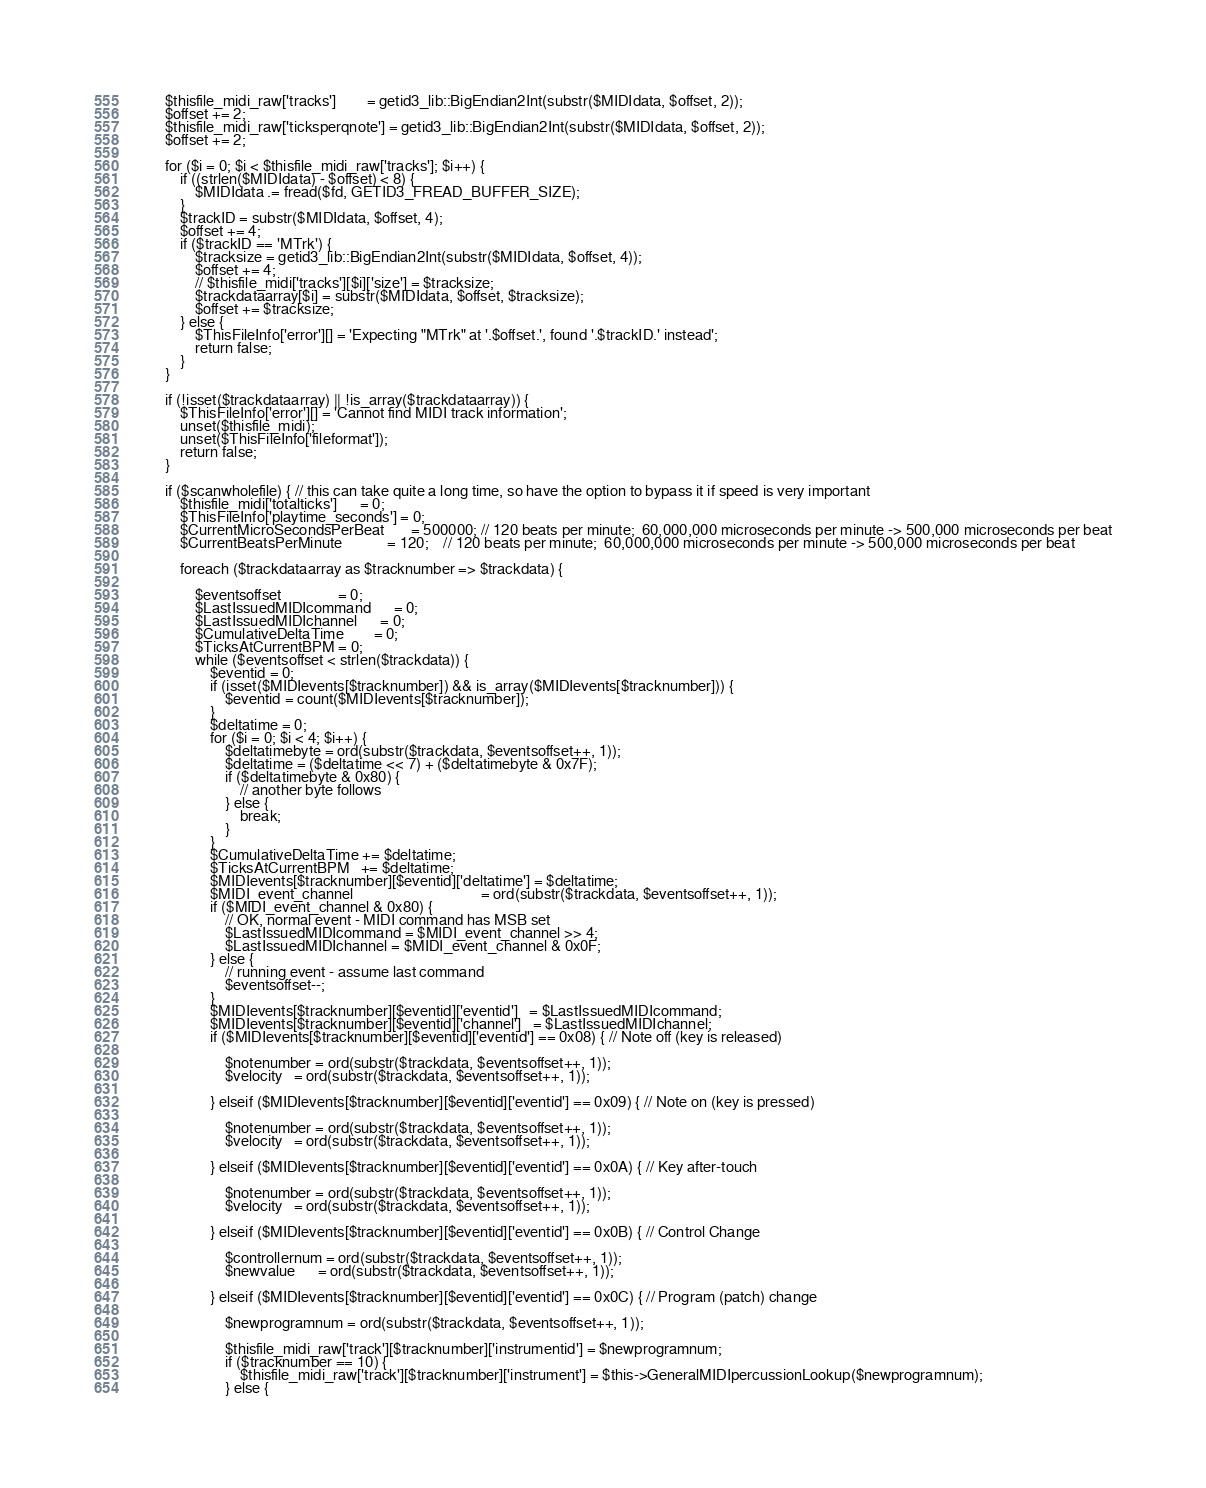Convert code to text. <code><loc_0><loc_0><loc_500><loc_500><_PHP_>		$thisfile_midi_raw['tracks']        = getid3_lib::BigEndian2Int(substr($MIDIdata, $offset, 2));
		$offset += 2;
		$thisfile_midi_raw['ticksperqnote'] = getid3_lib::BigEndian2Int(substr($MIDIdata, $offset, 2));
		$offset += 2;

		for ($i = 0; $i < $thisfile_midi_raw['tracks']; $i++) {
			if ((strlen($MIDIdata) - $offset) < 8) {
				$MIDIdata .= fread($fd, GETID3_FREAD_BUFFER_SIZE);
			}
			$trackID = substr($MIDIdata, $offset, 4);
			$offset += 4;
			if ($trackID == 'MTrk') {
				$tracksize = getid3_lib::BigEndian2Int(substr($MIDIdata, $offset, 4));
				$offset += 4;
				// $thisfile_midi['tracks'][$i]['size'] = $tracksize;
				$trackdataarray[$i] = substr($MIDIdata, $offset, $tracksize);
				$offset += $tracksize;
			} else {
				$ThisFileInfo['error'][] = 'Expecting "MTrk" at '.$offset.', found '.$trackID.' instead';
				return false;
			}
		}

		if (!isset($trackdataarray) || !is_array($trackdataarray)) {
			$ThisFileInfo['error'][] = 'Cannot find MIDI track information';
			unset($thisfile_midi);
			unset($ThisFileInfo['fileformat']);
			return false;
		}

		if ($scanwholefile) { // this can take quite a long time, so have the option to bypass it if speed is very important
			$thisfile_midi['totalticks']      = 0;
			$ThisFileInfo['playtime_seconds'] = 0;
			$CurrentMicroSecondsPerBeat       = 500000; // 120 beats per minute;  60,000,000 microseconds per minute -> 500,000 microseconds per beat
			$CurrentBeatsPerMinute            = 120;    // 120 beats per minute;  60,000,000 microseconds per minute -> 500,000 microseconds per beat

			foreach ($trackdataarray as $tracknumber => $trackdata) {

				$eventsoffset               = 0;
				$LastIssuedMIDIcommand      = 0;
				$LastIssuedMIDIchannel      = 0;
				$CumulativeDeltaTime        = 0;
				$TicksAtCurrentBPM = 0;
				while ($eventsoffset < strlen($trackdata)) {
					$eventid = 0;
					if (isset($MIDIevents[$tracknumber]) && is_array($MIDIevents[$tracknumber])) {
						$eventid = count($MIDIevents[$tracknumber]);
					}
					$deltatime = 0;
					for ($i = 0; $i < 4; $i++) {
						$deltatimebyte = ord(substr($trackdata, $eventsoffset++, 1));
						$deltatime = ($deltatime << 7) + ($deltatimebyte & 0x7F);
						if ($deltatimebyte & 0x80) {
							// another byte follows
						} else {
							break;
						}
					}
					$CumulativeDeltaTime += $deltatime;
					$TicksAtCurrentBPM   += $deltatime;
					$MIDIevents[$tracknumber][$eventid]['deltatime'] = $deltatime;
					$MIDI_event_channel                                  = ord(substr($trackdata, $eventsoffset++, 1));
					if ($MIDI_event_channel & 0x80) {
						// OK, normal event - MIDI command has MSB set
						$LastIssuedMIDIcommand = $MIDI_event_channel >> 4;
						$LastIssuedMIDIchannel = $MIDI_event_channel & 0x0F;
					} else {
						// running event - assume last command
						$eventsoffset--;
					}
					$MIDIevents[$tracknumber][$eventid]['eventid']   = $LastIssuedMIDIcommand;
					$MIDIevents[$tracknumber][$eventid]['channel']   = $LastIssuedMIDIchannel;
					if ($MIDIevents[$tracknumber][$eventid]['eventid'] == 0x08) { // Note off (key is released)

						$notenumber = ord(substr($trackdata, $eventsoffset++, 1));
						$velocity   = ord(substr($trackdata, $eventsoffset++, 1));

					} elseif ($MIDIevents[$tracknumber][$eventid]['eventid'] == 0x09) { // Note on (key is pressed)

						$notenumber = ord(substr($trackdata, $eventsoffset++, 1));
						$velocity   = ord(substr($trackdata, $eventsoffset++, 1));

					} elseif ($MIDIevents[$tracknumber][$eventid]['eventid'] == 0x0A) { // Key after-touch

						$notenumber = ord(substr($trackdata, $eventsoffset++, 1));
						$velocity   = ord(substr($trackdata, $eventsoffset++, 1));

					} elseif ($MIDIevents[$tracknumber][$eventid]['eventid'] == 0x0B) { // Control Change

						$controllernum = ord(substr($trackdata, $eventsoffset++, 1));
						$newvalue      = ord(substr($trackdata, $eventsoffset++, 1));

					} elseif ($MIDIevents[$tracknumber][$eventid]['eventid'] == 0x0C) { // Program (patch) change

						$newprogramnum = ord(substr($trackdata, $eventsoffset++, 1));

						$thisfile_midi_raw['track'][$tracknumber]['instrumentid'] = $newprogramnum;
						if ($tracknumber == 10) {
							$thisfile_midi_raw['track'][$tracknumber]['instrument'] = $this->GeneralMIDIpercussionLookup($newprogramnum);
						} else {</code> 